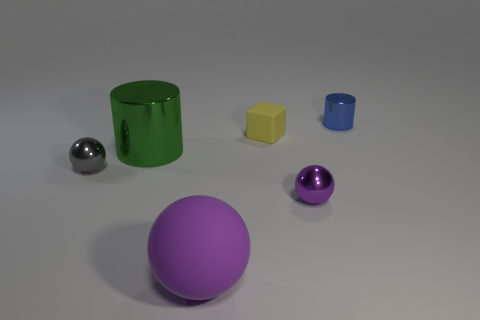Subtract all purple matte spheres. How many spheres are left? 2 Add 1 tiny rubber blocks. How many objects exist? 7 Subtract all gray spheres. How many spheres are left? 2 Subtract all cubes. How many objects are left? 5 Add 1 large green things. How many large green things are left? 2 Add 5 metal cylinders. How many metal cylinders exist? 7 Subtract 0 yellow spheres. How many objects are left? 6 Subtract 3 spheres. How many spheres are left? 0 Subtract all red cubes. Subtract all gray balls. How many cubes are left? 1 Subtract all yellow balls. How many blue cylinders are left? 1 